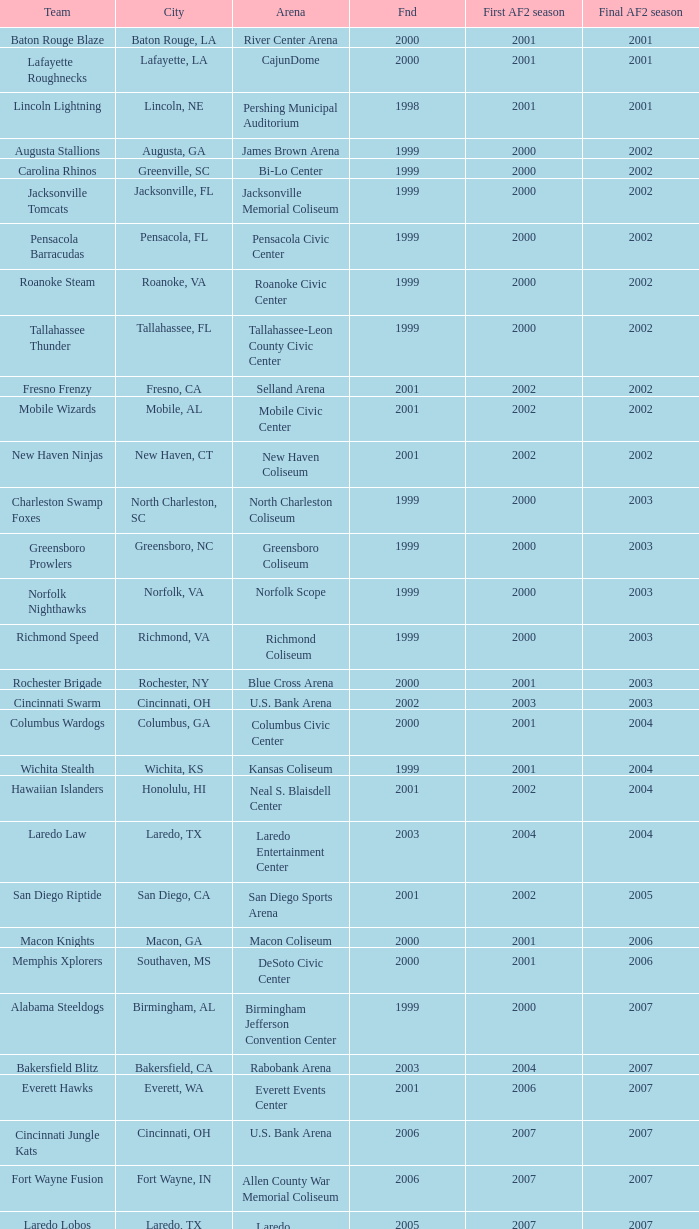How many founded years had a final af2 season prior to 2009 where the arena was the bi-lo center and the first af2 season was prior to 2000? 0.0. 